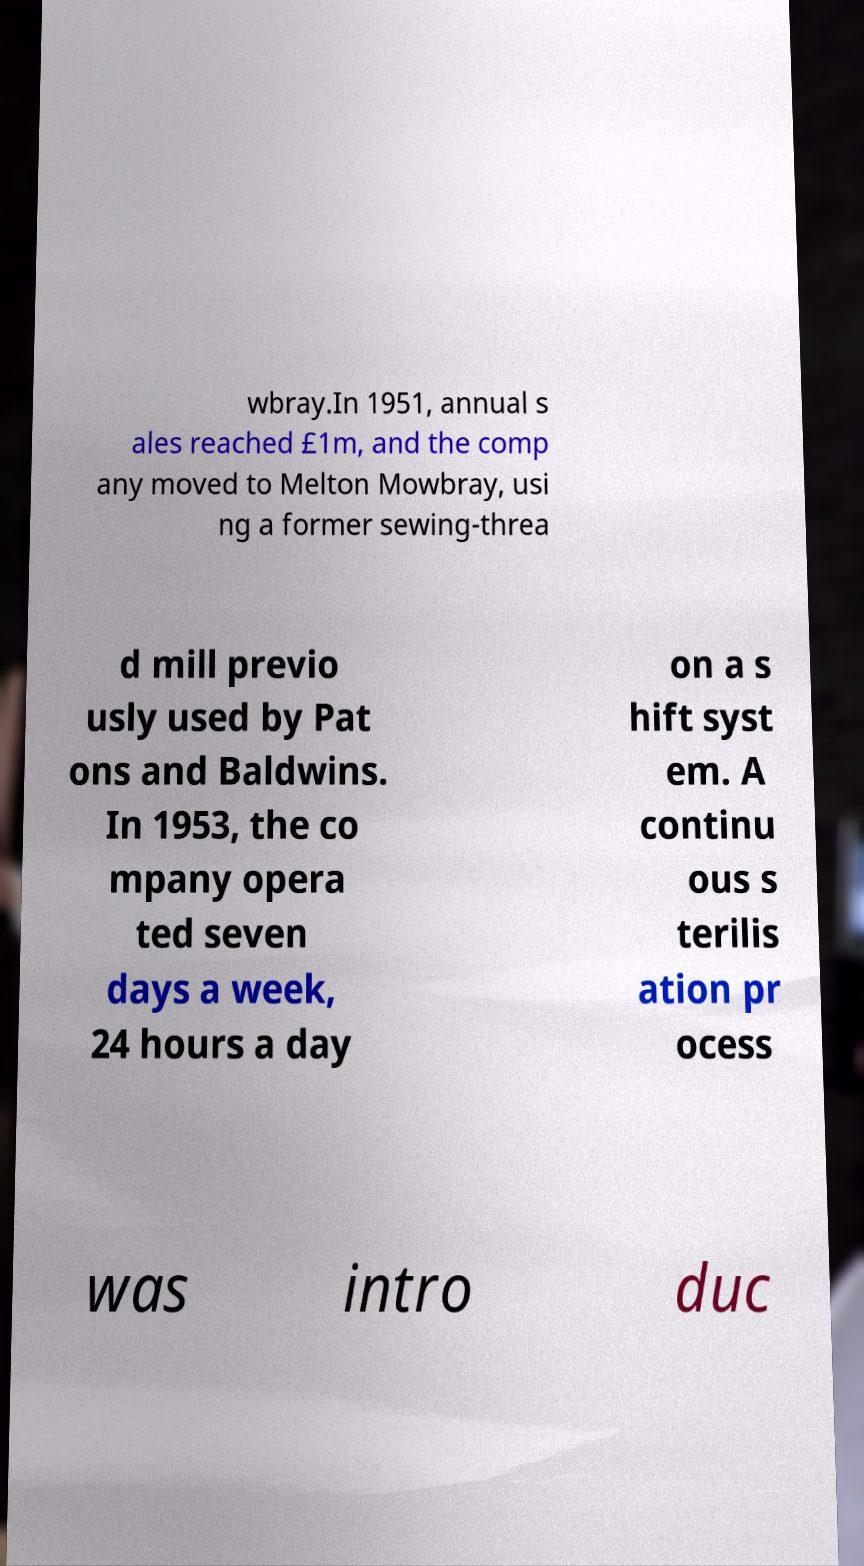What messages or text are displayed in this image? I need them in a readable, typed format. wbray.In 1951, annual s ales reached £1m, and the comp any moved to Melton Mowbray, usi ng a former sewing-threa d mill previo usly used by Pat ons and Baldwins. In 1953, the co mpany opera ted seven days a week, 24 hours a day on a s hift syst em. A continu ous s terilis ation pr ocess was intro duc 